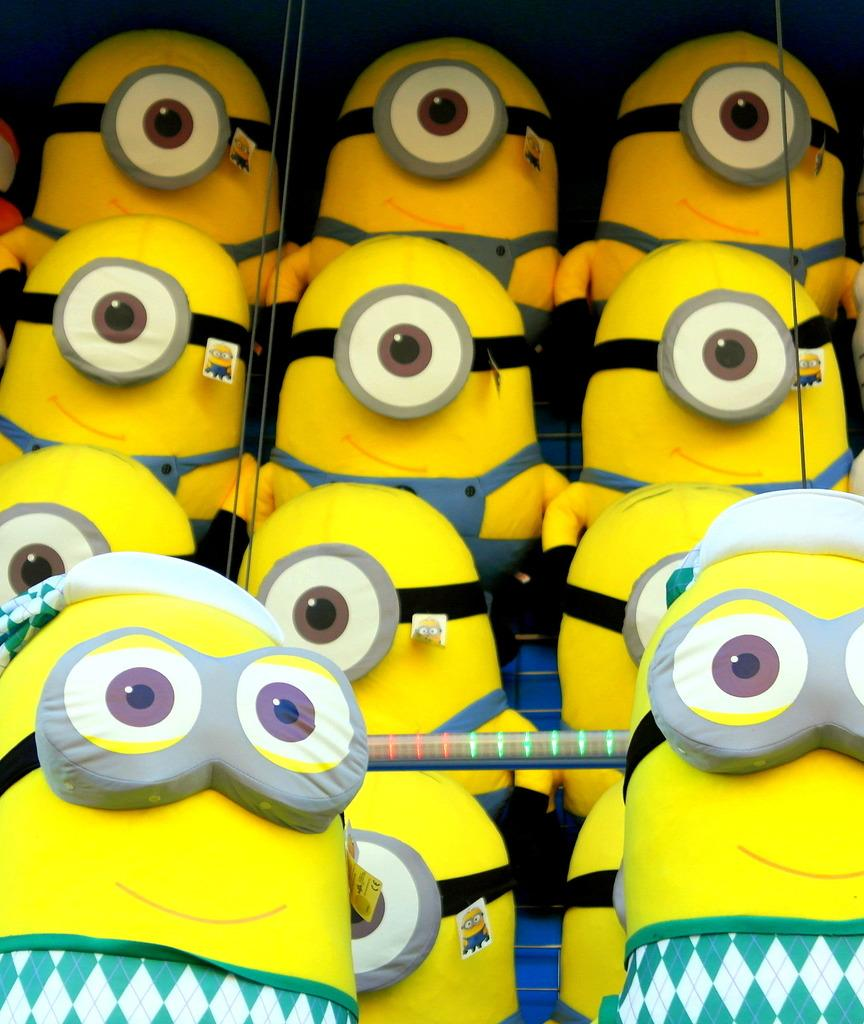What type of characters are present in the image? There are minions in the image. Can you see a hill in the background of the image? There is no hill visible in the image; it only features minions. What type of oil is being used by the minions in the image? There is no oil present in the image; it only features minions. 